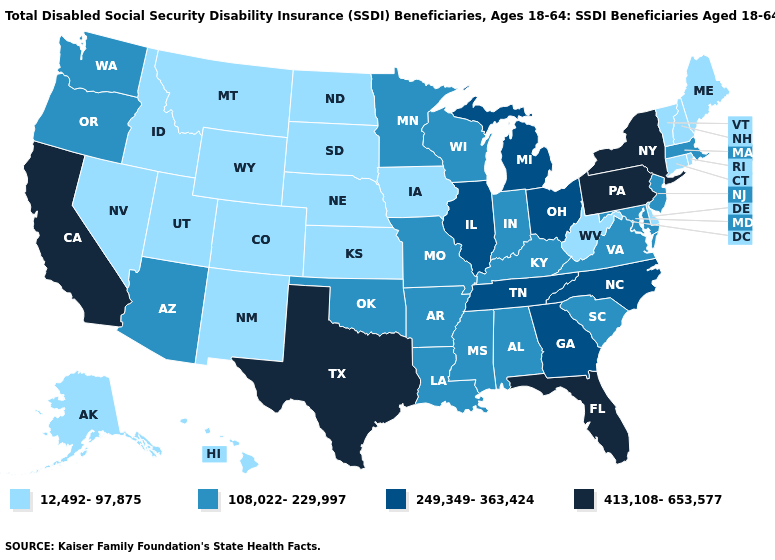Is the legend a continuous bar?
Short answer required. No. Does Kentucky have the highest value in the South?
Quick response, please. No. What is the lowest value in the USA?
Be succinct. 12,492-97,875. What is the lowest value in the USA?
Concise answer only. 12,492-97,875. What is the value of Missouri?
Be succinct. 108,022-229,997. Which states have the highest value in the USA?
Be succinct. California, Florida, New York, Pennsylvania, Texas. What is the value of Idaho?
Short answer required. 12,492-97,875. What is the value of Virginia?
Give a very brief answer. 108,022-229,997. What is the value of Iowa?
Quick response, please. 12,492-97,875. Which states have the highest value in the USA?
Be succinct. California, Florida, New York, Pennsylvania, Texas. Name the states that have a value in the range 108,022-229,997?
Give a very brief answer. Alabama, Arizona, Arkansas, Indiana, Kentucky, Louisiana, Maryland, Massachusetts, Minnesota, Mississippi, Missouri, New Jersey, Oklahoma, Oregon, South Carolina, Virginia, Washington, Wisconsin. What is the value of North Dakota?
Give a very brief answer. 12,492-97,875. What is the value of Louisiana?
Concise answer only. 108,022-229,997. Does Oregon have the same value as Delaware?
Concise answer only. No. 